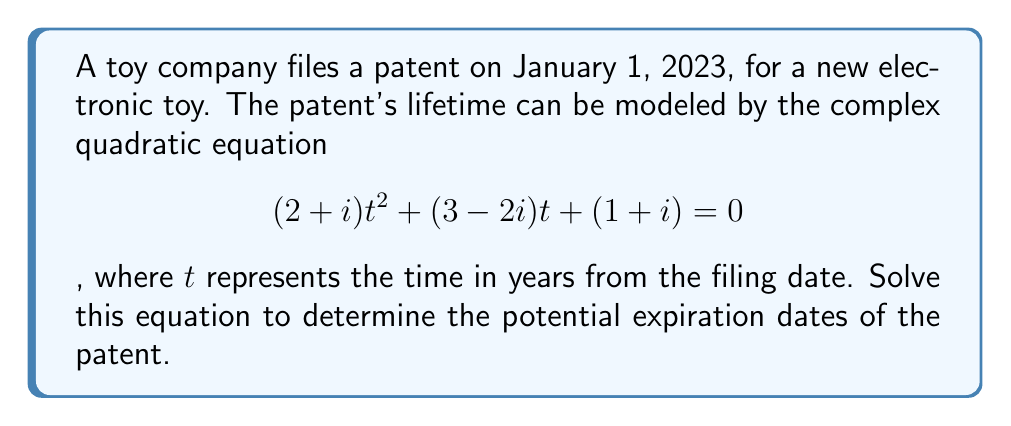Solve this math problem. To solve this complex quadratic equation, we'll use the quadratic formula:

$$t = \frac{-b \pm \sqrt{b^2 - 4ac}}{2a}$$

Where $a = 2+i$, $b = 3-2i$, and $c = 1+i$

Step 1: Calculate $b^2$
$b^2 = (3-2i)^2 = 9 - 12i + 4i^2 = 5 - 12i$

Step 2: Calculate $4ac$
$4ac = 4(2+i)(1+i) = 4(2+i+2i-1) = 4(1+3i) = 4 + 12i$

Step 3: Calculate $b^2 - 4ac$
$b^2 - 4ac = (5 - 12i) - (4 + 12i) = 1 - 24i$

Step 4: Calculate $\sqrt{b^2 - 4ac}$
$\sqrt{1 - 24i} = \sqrt{577}(\frac{1}{\sqrt{577}} - \frac{12}{\sqrt{577}}i) \approx 24.0208 - 12.0104i$

Step 5: Calculate $-b$
$-b = -(3-2i) = -3+2i$

Step 6: Apply the quadratic formula
$$t = \frac{(-3+2i) \pm (24.0208 - 12.0104i)}{2(2+i)}$$

Step 7: Simplify the numerator for both cases
$t_1 = \frac{21.0208 - 10.0104i}{2(2+i)}$
$t_2 = \frac{-27.0208 + 14.0104i}{2(2+i)}$

Step 8: Multiply numerator and denominator by the complex conjugate of the denominator
$t_1 = \frac{(21.0208 - 10.0104i)(2-i)}{(2+i)(2-i)} = \frac{42.0416 - 20.0208i - 21.0208i + 10.0104i^2}{4+1} = \frac{32.0312 - 41.0416i}{5}$
$t_2 = \frac{(-27.0208 + 14.0104i)(2-i)}{(2+i)(2-i)} = \frac{-54.0416 + 28.0208i + 27.0208i - 14.0104i^2}{4+1} = \frac{-68.0520 + 55.0416i}{5}$

Step 9: Simplify to get the final solutions
$t_1 \approx 6.4062 - 8.2083i$ years
$t_2 \approx -13.6104 + 11.0083i$ years

These complex solutions represent the potential expiration dates of the patent, measured in years from the filing date (January 1, 2023).
Answer: $t_1 \approx 6.4062 - 8.2083i$ years, $t_2 \approx -13.6104 + 11.0083i$ years 